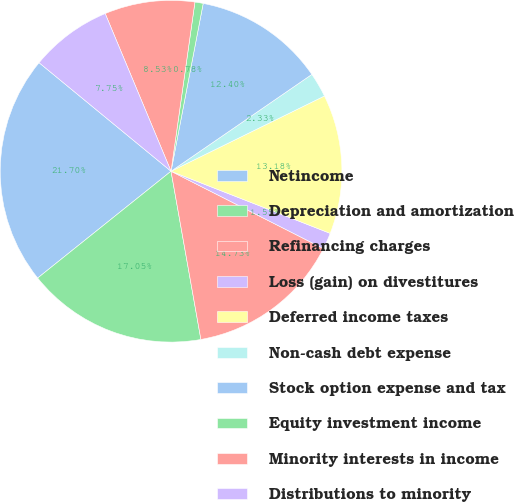<chart> <loc_0><loc_0><loc_500><loc_500><pie_chart><fcel>Netincome<fcel>Depreciation and amortization<fcel>Refinancing charges<fcel>Loss (gain) on divestitures<fcel>Deferred income taxes<fcel>Non-cash debt expense<fcel>Stock option expense and tax<fcel>Equity investment income<fcel>Minority interests in income<fcel>Distributions to minority<nl><fcel>21.7%<fcel>17.05%<fcel>14.73%<fcel>1.55%<fcel>13.18%<fcel>2.33%<fcel>12.4%<fcel>0.78%<fcel>8.53%<fcel>7.75%<nl></chart> 